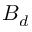Convert formula to latex. <formula><loc_0><loc_0><loc_500><loc_500>B _ { d }</formula> 